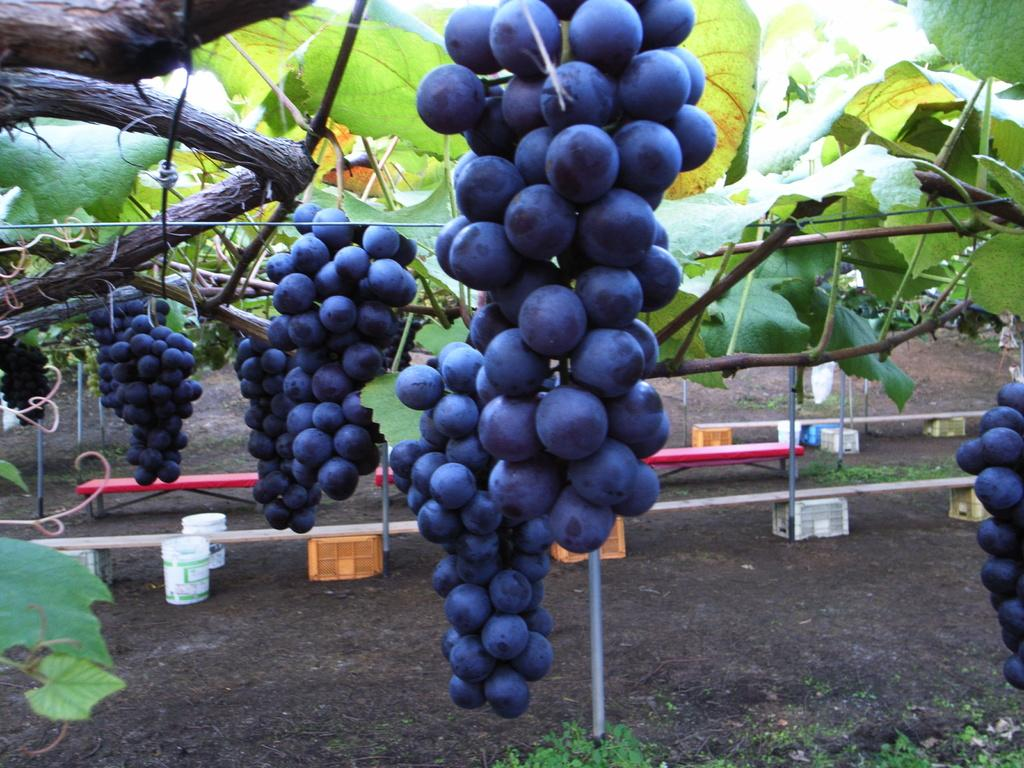What type of vegetation can be seen in the image? There are branches with leaves in the image. What type of fruit is present in the image? There are grapes in the image. What objects are on the ground in the image? There are buckets, poles, baskets, plants, and other objects on the ground in the image. What type of drum can be seen in the image? There is no drum present in the image. What is the weight of the grapes in the image? The weight of the grapes cannot be determined from the image alone, as it does not provide any information about their size or quantity. 